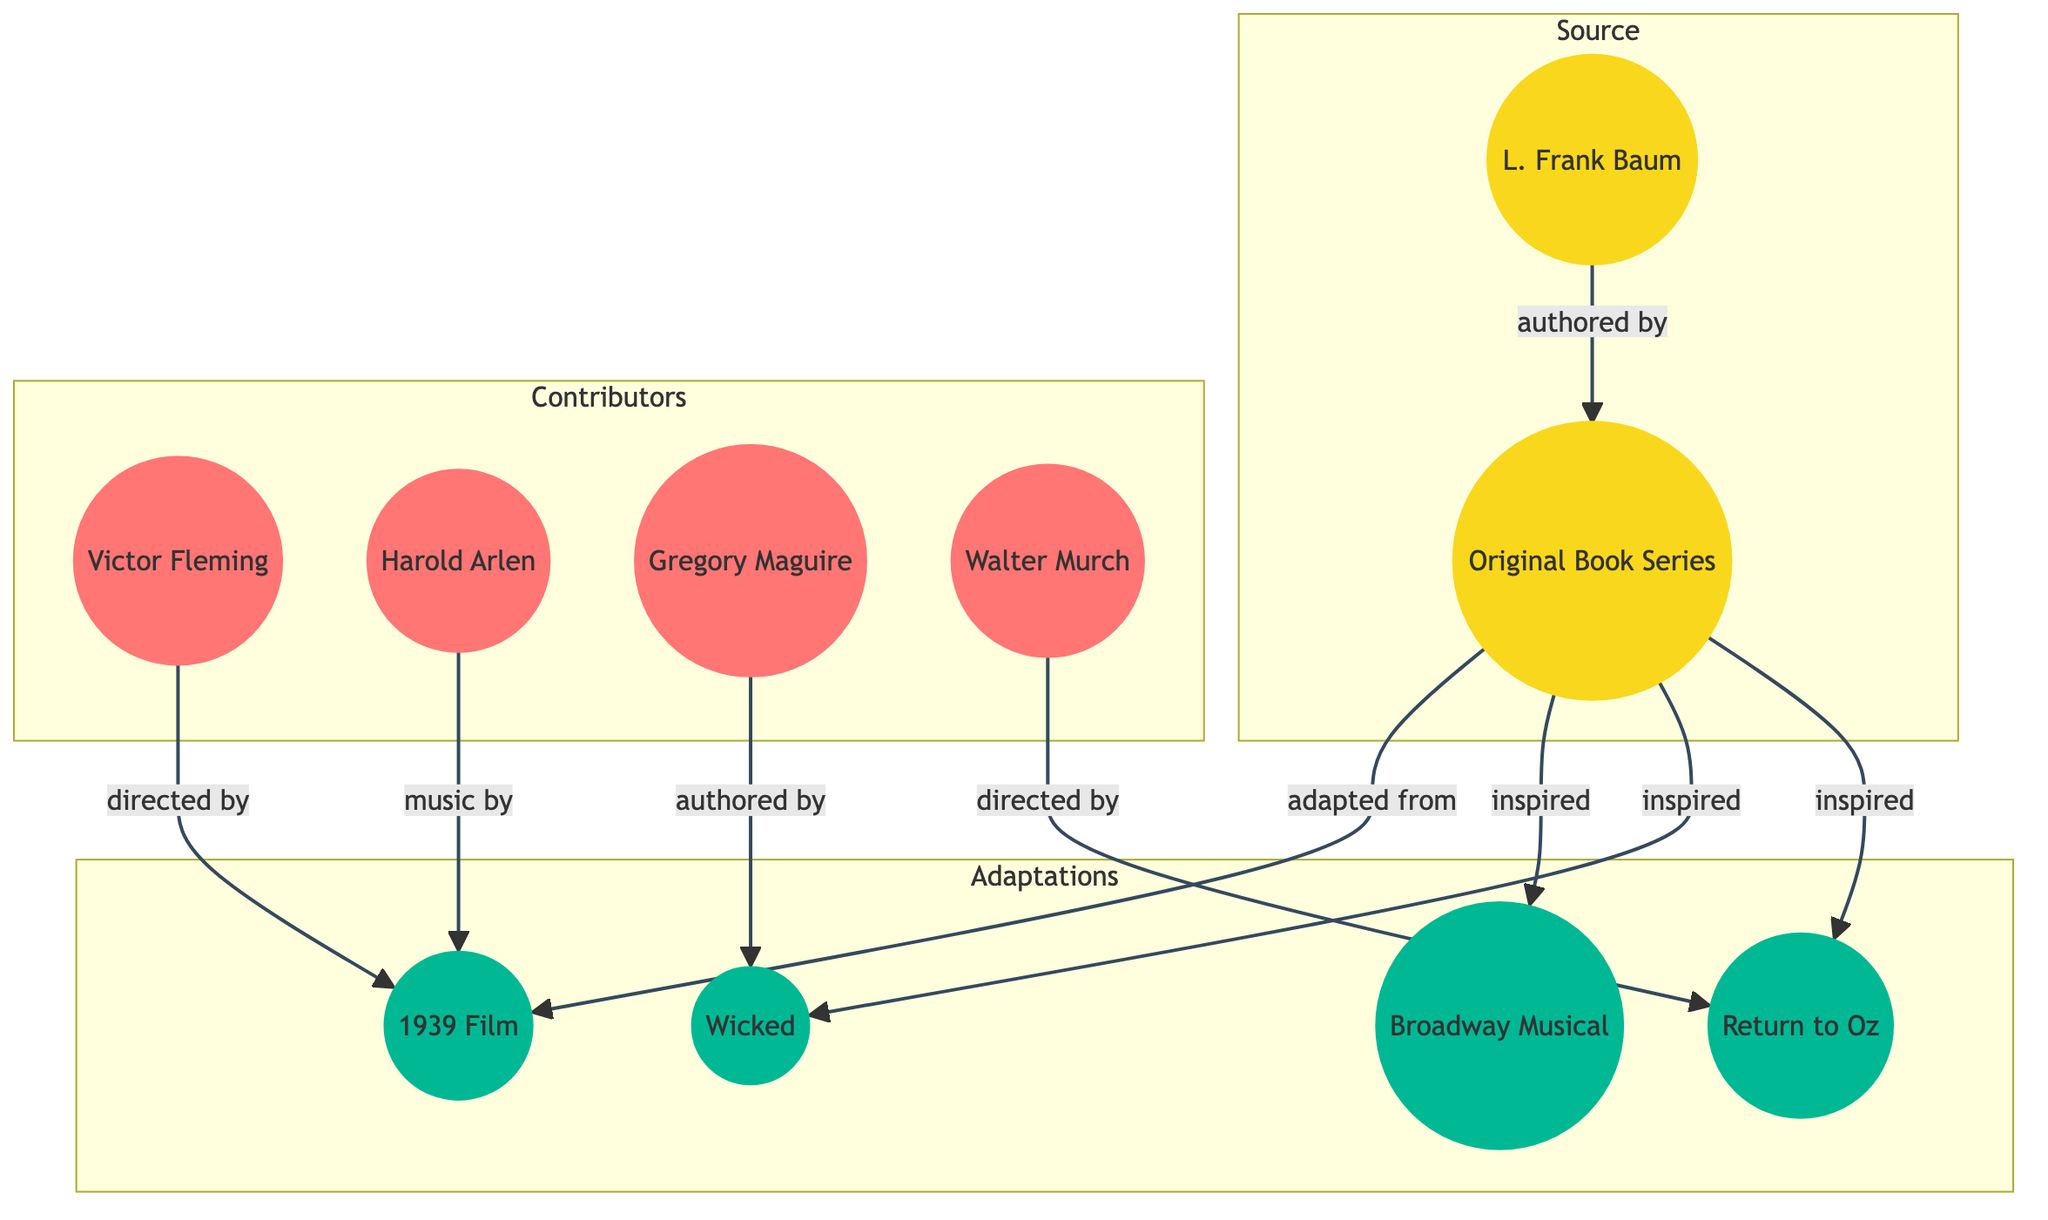What is the source material for the adaptations? The diagram indicates that the source material is the "Original Book Series." It is labeled under the "Source" subgraph, linked as the originating point for the various adaptations.
Answer: Original Book Series Who directed the 1939 Film? The diagram shows an edge from "Victor Fleming" to "1939 Film" labeled "directed by," indicating that Victor Fleming is the director of this adaptation.
Answer: Victor Fleming How many adaptations are inspired by the original book? The diagram lists three adaptations inspired by the original book: the Broadway Musical, Wicked, and Return to Oz. This can be identified by examining the connections labeled "inspired" from the "Original Book Series" node.
Answer: 3 Which adaptation was authored by Gregory Maguire? According to the diagram, there is a direct link from "Gregory Maguire" to "Wicked," labeled "authored by," indicating that Gregory Maguire is the author of this adaptation.
Answer: Wicked What is the relationship between L. Frank Baum and the Original Book Series? The diagram illustrates that L. Frank Baum has an edge leading to the "Original Book Series" node, labeled "authored by," which showcases that he is the author of the source material.
Answer: authored by Which adaptation is directed by Walter Murch? The edge from "Walter Murch" to "Return to Oz" labeled "directed by" shows that Walter Murch directed this particular adaptation.
Answer: Return to Oz Which adaptation was adapted from the original book? The 1939 Film is the only adaptation directly labeled as "adapted from" the "Original Book Series," indicating its direct connection and derivation from the source material.
Answer: 1939 Film How many contributors are involved in the adaptations? The diagram includes four contributors: Victor Fleming, Harold Arlen, Gregory Maguire, and Walter Murch, each connected to the adaptations they contributed to. This counts each distinct contributor involved in the adaptations.
Answer: 4 Which adaptation is inspired by the original book but does not involve L. Frank Baum as an author? Wicked and Return to Oz are both inspired by the original book, and they do not involve Baum as an author, but Wicked is specifically authored by Gregory Maguire, distinguishing it from Baum's authorship.
Answer: Wicked, Return to Oz 